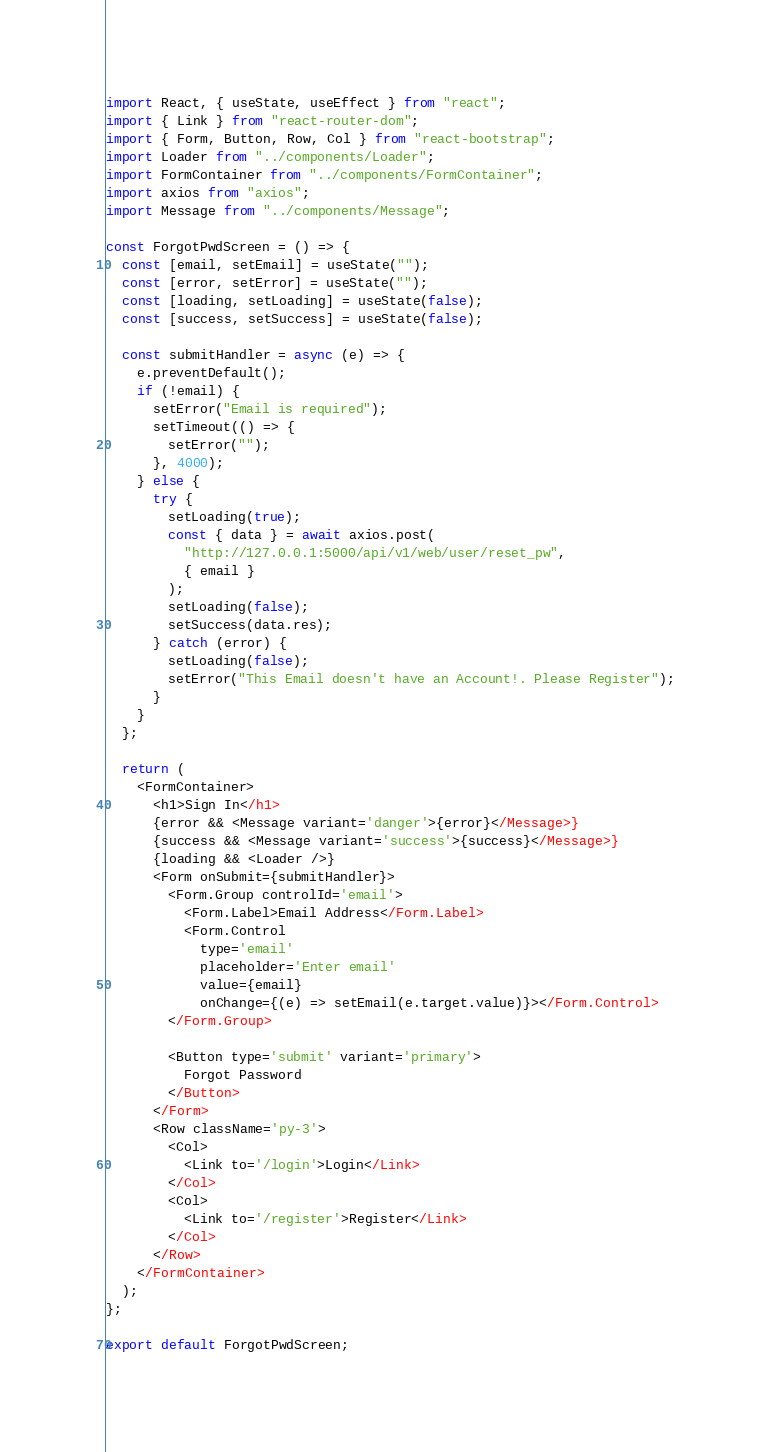<code> <loc_0><loc_0><loc_500><loc_500><_JavaScript_>import React, { useState, useEffect } from "react";
import { Link } from "react-router-dom";
import { Form, Button, Row, Col } from "react-bootstrap";
import Loader from "../components/Loader";
import FormContainer from "../components/FormContainer";
import axios from "axios";
import Message from "../components/Message";

const ForgotPwdScreen = () => {
  const [email, setEmail] = useState("");
  const [error, setError] = useState("");
  const [loading, setLoading] = useState(false);
  const [success, setSuccess] = useState(false);

  const submitHandler = async (e) => {
    e.preventDefault();
    if (!email) {
      setError("Email is required");
      setTimeout(() => {
        setError("");
      }, 4000);
    } else {
      try {
        setLoading(true);
        const { data } = await axios.post(
          "http://127.0.0.1:5000/api/v1/web/user/reset_pw",
          { email }
        );
        setLoading(false);
        setSuccess(data.res);
      } catch (error) {
        setLoading(false);
        setError("This Email doesn't have an Account!. Please Register");
      }
    }
  };

  return (
    <FormContainer>
      <h1>Sign In</h1>
      {error && <Message variant='danger'>{error}</Message>}
      {success && <Message variant='success'>{success}</Message>}
      {loading && <Loader />}
      <Form onSubmit={submitHandler}>
        <Form.Group controlId='email'>
          <Form.Label>Email Address</Form.Label>
          <Form.Control
            type='email'
            placeholder='Enter email'
            value={email}
            onChange={(e) => setEmail(e.target.value)}></Form.Control>
        </Form.Group>

        <Button type='submit' variant='primary'>
          Forgot Password
        </Button>
      </Form>
      <Row className='py-3'>
        <Col>
          <Link to='/login'>Login</Link>
        </Col>
        <Col>
          <Link to='/register'>Register</Link>
        </Col>
      </Row>
    </FormContainer>
  );
};

export default ForgotPwdScreen;
</code> 